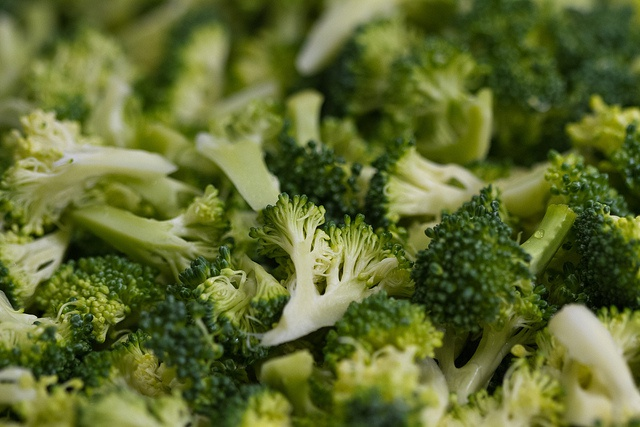Describe the objects in this image and their specific colors. I can see broccoli in darkgreen, black, olive, and tan tones, broccoli in darkgreen and olive tones, broccoli in darkgreen, olive, and beige tones, broccoli in darkgreen, black, and olive tones, and broccoli in darkgreen and olive tones in this image. 